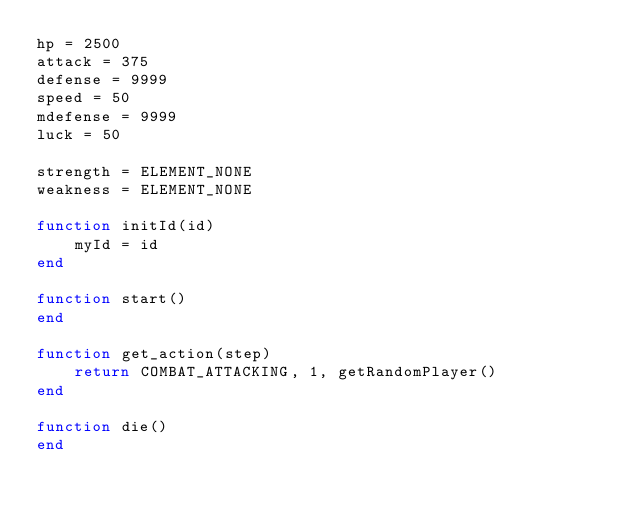<code> <loc_0><loc_0><loc_500><loc_500><_Lua_>hp = 2500
attack = 375
defense = 9999
speed = 50
mdefense = 9999
luck = 50

strength = ELEMENT_NONE
weakness = ELEMENT_NONE

function initId(id)
	myId = id
end

function start()
end

function get_action(step)
	return COMBAT_ATTACKING, 1, getRandomPlayer()
end

function die()
end
</code> 